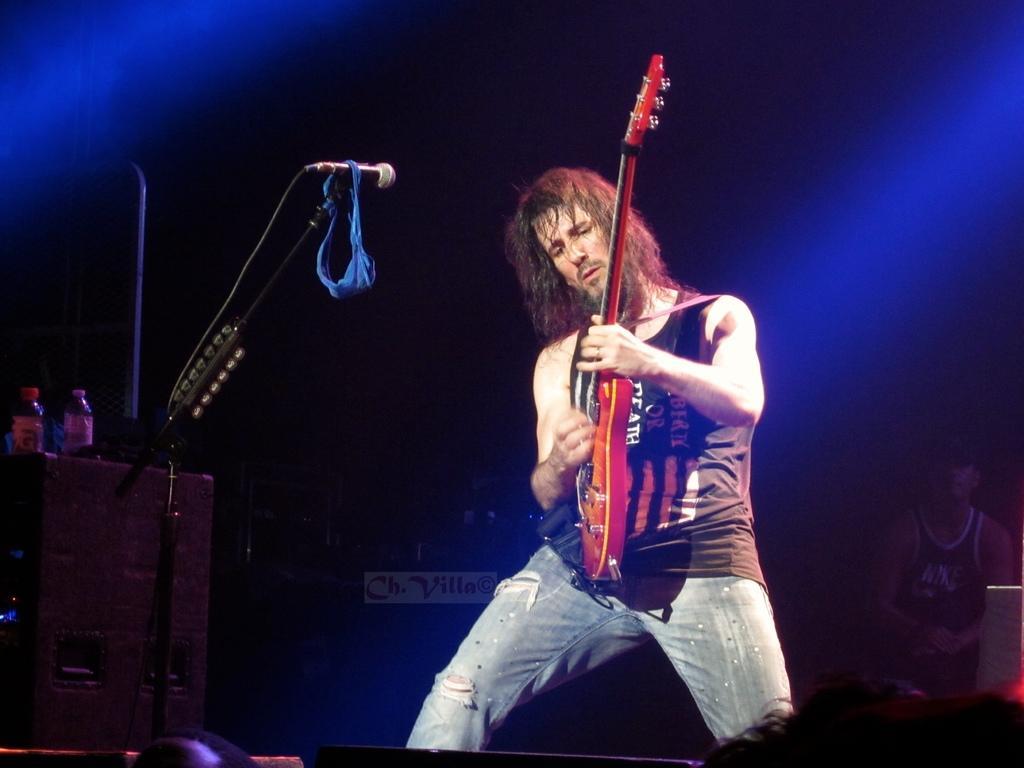In one or two sentences, can you explain what this image depicts? In this image i can see a man standing holding a guitar and playing, in front of a man there is a micro phone,there are two bottles beside the microphone,back ground i can see a man setting. 